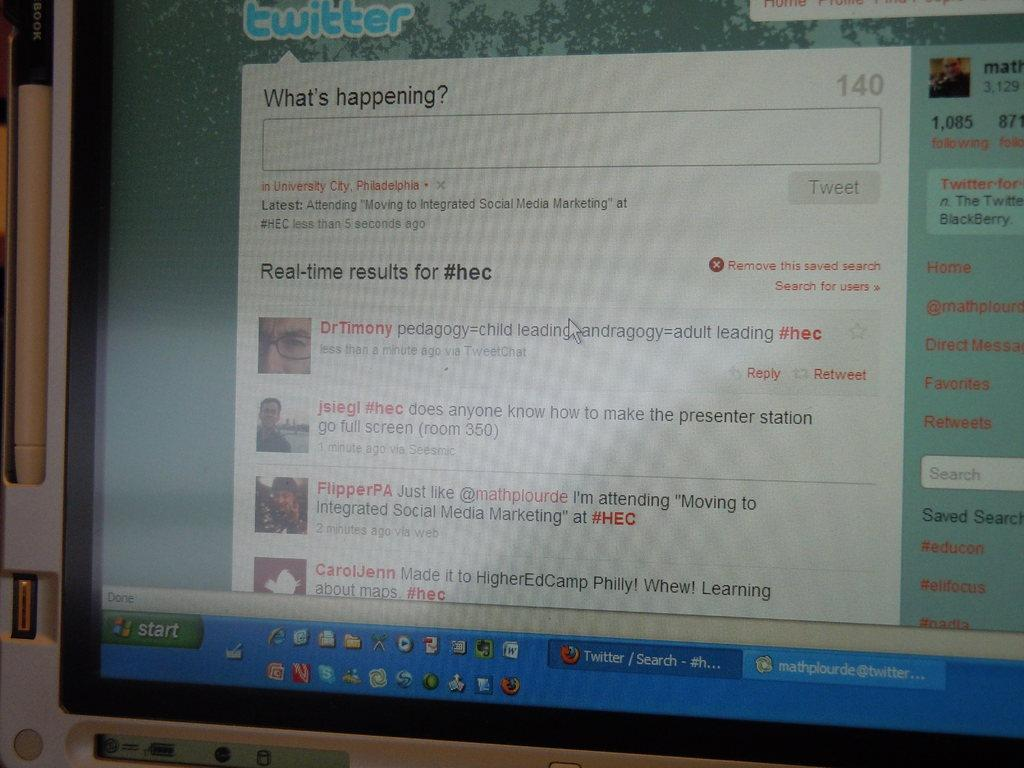Provide a one-sentence caption for the provided image. A computer with Twitter on its web browser. 